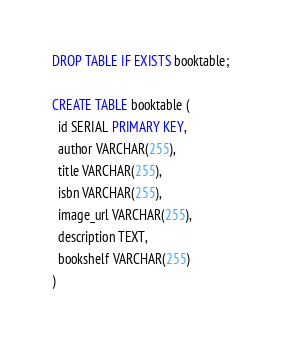<code> <loc_0><loc_0><loc_500><loc_500><_SQL_>DROP TABLE IF EXISTS booktable;

CREATE TABLE booktable (
  id SERIAL PRIMARY KEY,
  author VARCHAR(255),
  title VARCHAR(255),
  isbn VARCHAR(255),
  image_url VARCHAR(255),
  description TEXT,
  bookshelf VARCHAR(255)
)</code> 